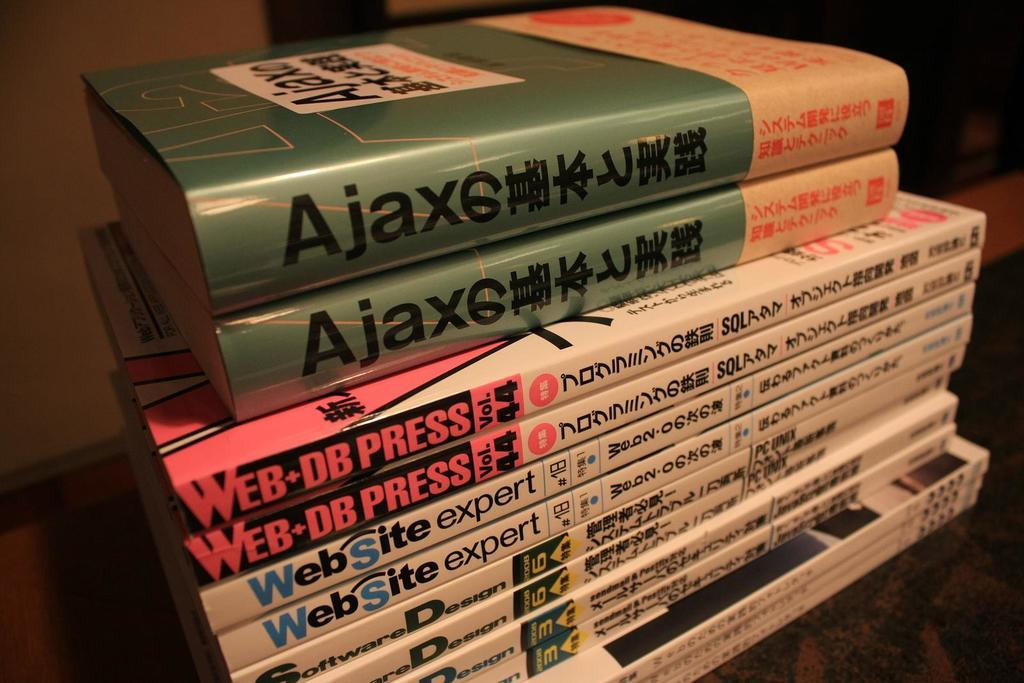<image>
Relay a brief, clear account of the picture shown. Several books are stacked up, including a few Web Site Expert books. 